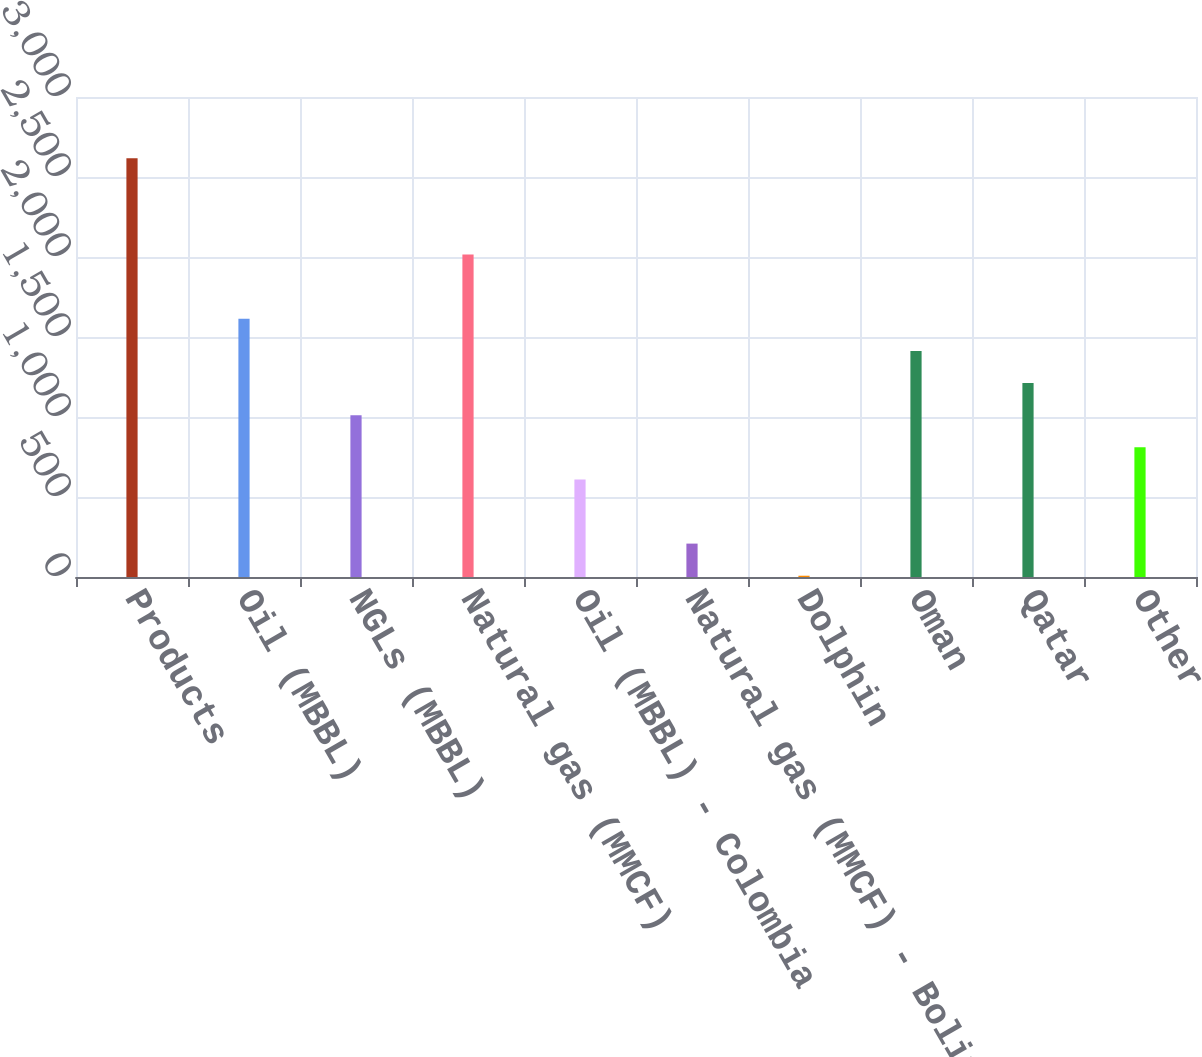Convert chart. <chart><loc_0><loc_0><loc_500><loc_500><bar_chart><fcel>Products<fcel>Oil (MBBL)<fcel>NGLs (MBBL)<fcel>Natural gas (MMCF)<fcel>Oil (MBBL) - Colombia<fcel>Natural gas (MMCF) - Bolivia<fcel>Dolphin<fcel>Oman<fcel>Qatar<fcel>Other<nl><fcel>2617.1<fcel>1613.6<fcel>1011.5<fcel>2015<fcel>610.1<fcel>208.7<fcel>8<fcel>1412.9<fcel>1212.2<fcel>810.8<nl></chart> 